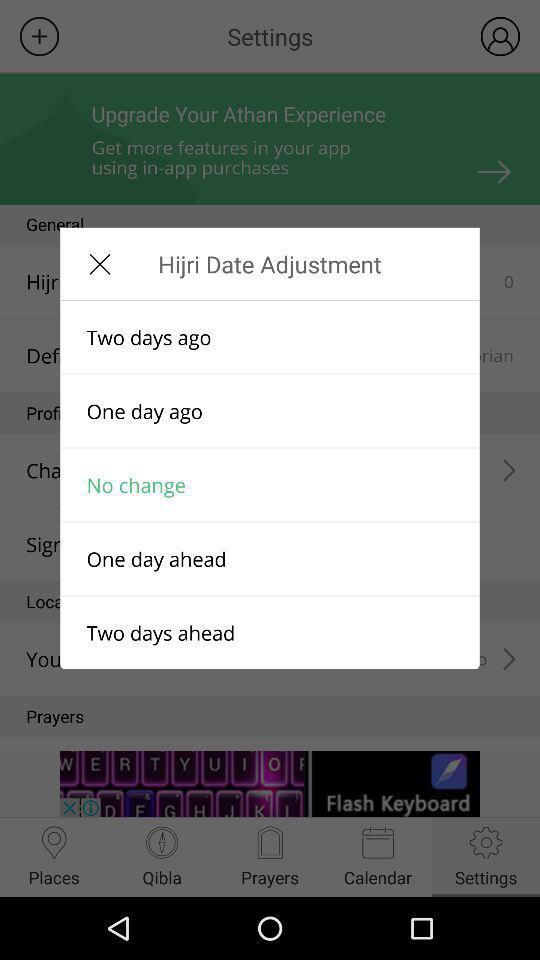Is one day ago selected?
When the provided information is insufficient, respond with <no answer>. <no answer> 